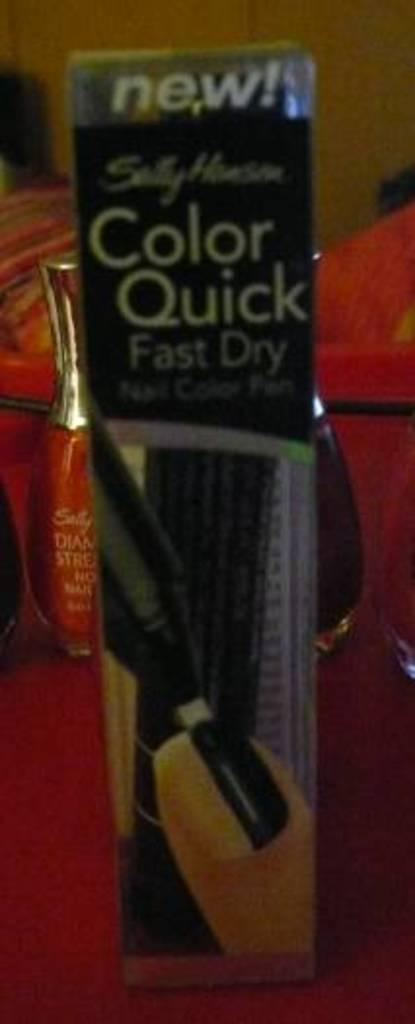<image>
Relay a brief, clear account of the picture shown. Sally Hansen brand quick dry nail polish in a box. 